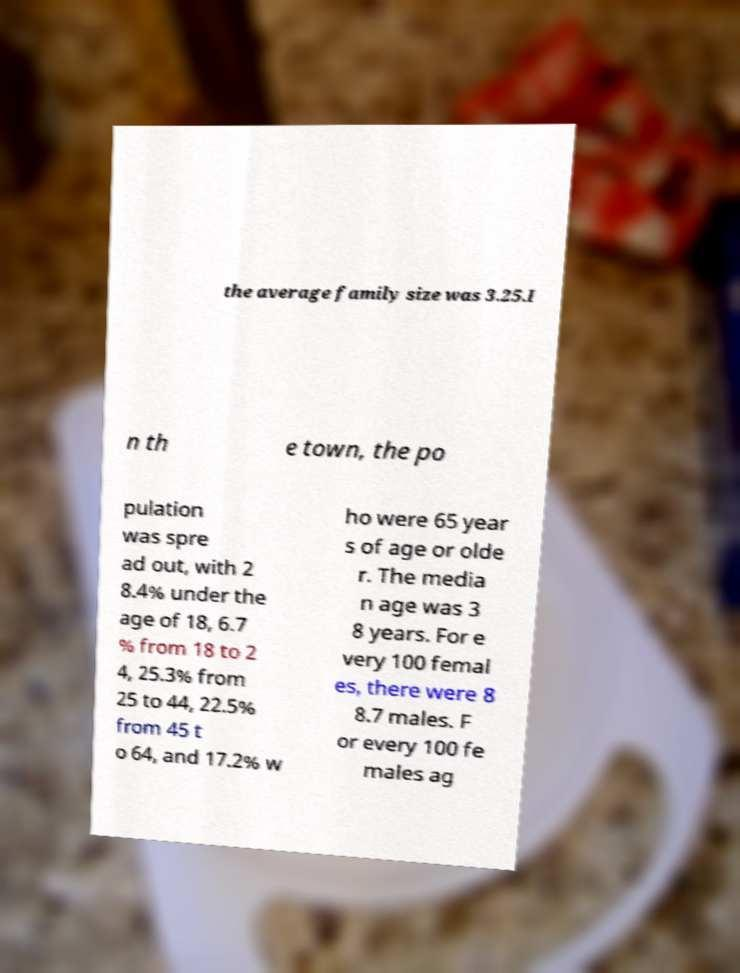I need the written content from this picture converted into text. Can you do that? the average family size was 3.25.I n th e town, the po pulation was spre ad out, with 2 8.4% under the age of 18, 6.7 % from 18 to 2 4, 25.3% from 25 to 44, 22.5% from 45 t o 64, and 17.2% w ho were 65 year s of age or olde r. The media n age was 3 8 years. For e very 100 femal es, there were 8 8.7 males. F or every 100 fe males ag 